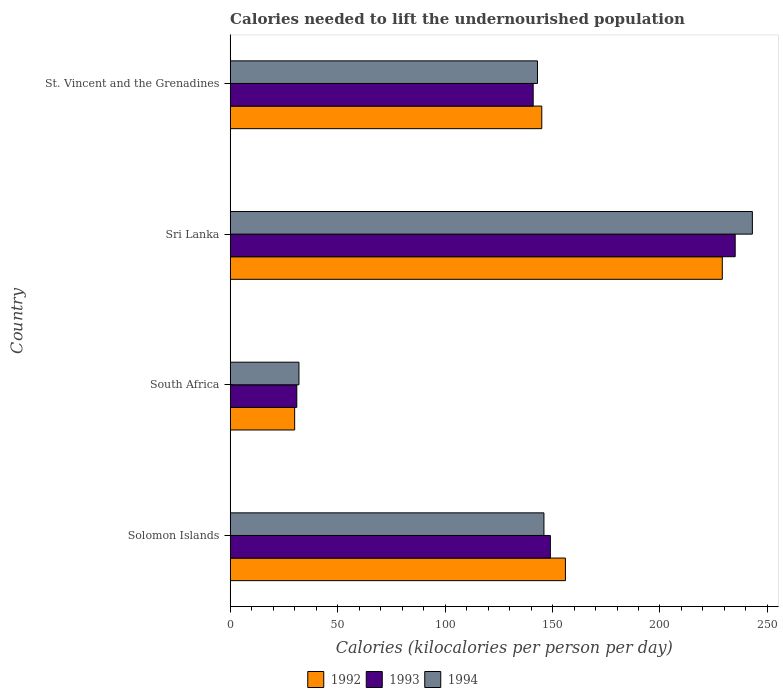How many groups of bars are there?
Offer a very short reply. 4. Are the number of bars per tick equal to the number of legend labels?
Provide a short and direct response. Yes. How many bars are there on the 1st tick from the top?
Offer a very short reply. 3. What is the label of the 1st group of bars from the top?
Your answer should be very brief. St. Vincent and the Grenadines. In how many cases, is the number of bars for a given country not equal to the number of legend labels?
Give a very brief answer. 0. What is the total calories needed to lift the undernourished population in 1994 in St. Vincent and the Grenadines?
Provide a succinct answer. 143. Across all countries, what is the maximum total calories needed to lift the undernourished population in 1992?
Your response must be concise. 229. Across all countries, what is the minimum total calories needed to lift the undernourished population in 1992?
Your response must be concise. 30. In which country was the total calories needed to lift the undernourished population in 1993 maximum?
Your answer should be very brief. Sri Lanka. In which country was the total calories needed to lift the undernourished population in 1994 minimum?
Provide a succinct answer. South Africa. What is the total total calories needed to lift the undernourished population in 1992 in the graph?
Offer a very short reply. 560. What is the difference between the total calories needed to lift the undernourished population in 1992 in Solomon Islands and that in Sri Lanka?
Your answer should be compact. -73. What is the difference between the total calories needed to lift the undernourished population in 1994 in Sri Lanka and the total calories needed to lift the undernourished population in 1993 in South Africa?
Keep it short and to the point. 212. What is the average total calories needed to lift the undernourished population in 1992 per country?
Provide a succinct answer. 140. What is the ratio of the total calories needed to lift the undernourished population in 1994 in South Africa to that in Sri Lanka?
Offer a terse response. 0.13. Is the total calories needed to lift the undernourished population in 1992 in South Africa less than that in Sri Lanka?
Your answer should be very brief. Yes. Is the difference between the total calories needed to lift the undernourished population in 1994 in South Africa and St. Vincent and the Grenadines greater than the difference between the total calories needed to lift the undernourished population in 1993 in South Africa and St. Vincent and the Grenadines?
Offer a terse response. No. What is the difference between the highest and the second highest total calories needed to lift the undernourished population in 1992?
Your answer should be compact. 73. What is the difference between the highest and the lowest total calories needed to lift the undernourished population in 1992?
Your answer should be compact. 199. What does the 2nd bar from the top in St. Vincent and the Grenadines represents?
Offer a terse response. 1993. What does the 3rd bar from the bottom in South Africa represents?
Make the answer very short. 1994. How many bars are there?
Provide a succinct answer. 12. Are all the bars in the graph horizontal?
Offer a terse response. Yes. Are the values on the major ticks of X-axis written in scientific E-notation?
Ensure brevity in your answer.  No. Does the graph contain any zero values?
Your answer should be very brief. No. How many legend labels are there?
Give a very brief answer. 3. How are the legend labels stacked?
Offer a terse response. Horizontal. What is the title of the graph?
Ensure brevity in your answer.  Calories needed to lift the undernourished population. Does "1985" appear as one of the legend labels in the graph?
Provide a short and direct response. No. What is the label or title of the X-axis?
Give a very brief answer. Calories (kilocalories per person per day). What is the label or title of the Y-axis?
Your answer should be compact. Country. What is the Calories (kilocalories per person per day) of 1992 in Solomon Islands?
Make the answer very short. 156. What is the Calories (kilocalories per person per day) of 1993 in Solomon Islands?
Provide a succinct answer. 149. What is the Calories (kilocalories per person per day) of 1994 in Solomon Islands?
Provide a succinct answer. 146. What is the Calories (kilocalories per person per day) of 1992 in South Africa?
Keep it short and to the point. 30. What is the Calories (kilocalories per person per day) in 1992 in Sri Lanka?
Your answer should be compact. 229. What is the Calories (kilocalories per person per day) of 1993 in Sri Lanka?
Provide a short and direct response. 235. What is the Calories (kilocalories per person per day) in 1994 in Sri Lanka?
Offer a terse response. 243. What is the Calories (kilocalories per person per day) in 1992 in St. Vincent and the Grenadines?
Give a very brief answer. 145. What is the Calories (kilocalories per person per day) in 1993 in St. Vincent and the Grenadines?
Provide a short and direct response. 141. What is the Calories (kilocalories per person per day) in 1994 in St. Vincent and the Grenadines?
Your response must be concise. 143. Across all countries, what is the maximum Calories (kilocalories per person per day) in 1992?
Your answer should be very brief. 229. Across all countries, what is the maximum Calories (kilocalories per person per day) of 1993?
Provide a succinct answer. 235. Across all countries, what is the maximum Calories (kilocalories per person per day) in 1994?
Your response must be concise. 243. Across all countries, what is the minimum Calories (kilocalories per person per day) of 1994?
Give a very brief answer. 32. What is the total Calories (kilocalories per person per day) in 1992 in the graph?
Give a very brief answer. 560. What is the total Calories (kilocalories per person per day) in 1993 in the graph?
Offer a terse response. 556. What is the total Calories (kilocalories per person per day) of 1994 in the graph?
Keep it short and to the point. 564. What is the difference between the Calories (kilocalories per person per day) of 1992 in Solomon Islands and that in South Africa?
Your answer should be very brief. 126. What is the difference between the Calories (kilocalories per person per day) in 1993 in Solomon Islands and that in South Africa?
Ensure brevity in your answer.  118. What is the difference between the Calories (kilocalories per person per day) of 1994 in Solomon Islands and that in South Africa?
Your response must be concise. 114. What is the difference between the Calories (kilocalories per person per day) in 1992 in Solomon Islands and that in Sri Lanka?
Provide a succinct answer. -73. What is the difference between the Calories (kilocalories per person per day) of 1993 in Solomon Islands and that in Sri Lanka?
Give a very brief answer. -86. What is the difference between the Calories (kilocalories per person per day) in 1994 in Solomon Islands and that in Sri Lanka?
Your response must be concise. -97. What is the difference between the Calories (kilocalories per person per day) in 1992 in Solomon Islands and that in St. Vincent and the Grenadines?
Make the answer very short. 11. What is the difference between the Calories (kilocalories per person per day) in 1993 in Solomon Islands and that in St. Vincent and the Grenadines?
Make the answer very short. 8. What is the difference between the Calories (kilocalories per person per day) in 1994 in Solomon Islands and that in St. Vincent and the Grenadines?
Ensure brevity in your answer.  3. What is the difference between the Calories (kilocalories per person per day) of 1992 in South Africa and that in Sri Lanka?
Offer a very short reply. -199. What is the difference between the Calories (kilocalories per person per day) in 1993 in South Africa and that in Sri Lanka?
Your answer should be compact. -204. What is the difference between the Calories (kilocalories per person per day) in 1994 in South Africa and that in Sri Lanka?
Provide a short and direct response. -211. What is the difference between the Calories (kilocalories per person per day) of 1992 in South Africa and that in St. Vincent and the Grenadines?
Your response must be concise. -115. What is the difference between the Calories (kilocalories per person per day) of 1993 in South Africa and that in St. Vincent and the Grenadines?
Give a very brief answer. -110. What is the difference between the Calories (kilocalories per person per day) in 1994 in South Africa and that in St. Vincent and the Grenadines?
Provide a short and direct response. -111. What is the difference between the Calories (kilocalories per person per day) of 1992 in Sri Lanka and that in St. Vincent and the Grenadines?
Your answer should be very brief. 84. What is the difference between the Calories (kilocalories per person per day) in 1993 in Sri Lanka and that in St. Vincent and the Grenadines?
Provide a succinct answer. 94. What is the difference between the Calories (kilocalories per person per day) in 1994 in Sri Lanka and that in St. Vincent and the Grenadines?
Your response must be concise. 100. What is the difference between the Calories (kilocalories per person per day) of 1992 in Solomon Islands and the Calories (kilocalories per person per day) of 1993 in South Africa?
Make the answer very short. 125. What is the difference between the Calories (kilocalories per person per day) of 1992 in Solomon Islands and the Calories (kilocalories per person per day) of 1994 in South Africa?
Make the answer very short. 124. What is the difference between the Calories (kilocalories per person per day) of 1993 in Solomon Islands and the Calories (kilocalories per person per day) of 1994 in South Africa?
Make the answer very short. 117. What is the difference between the Calories (kilocalories per person per day) of 1992 in Solomon Islands and the Calories (kilocalories per person per day) of 1993 in Sri Lanka?
Keep it short and to the point. -79. What is the difference between the Calories (kilocalories per person per day) of 1992 in Solomon Islands and the Calories (kilocalories per person per day) of 1994 in Sri Lanka?
Offer a very short reply. -87. What is the difference between the Calories (kilocalories per person per day) of 1993 in Solomon Islands and the Calories (kilocalories per person per day) of 1994 in Sri Lanka?
Give a very brief answer. -94. What is the difference between the Calories (kilocalories per person per day) in 1992 in Solomon Islands and the Calories (kilocalories per person per day) in 1993 in St. Vincent and the Grenadines?
Your answer should be very brief. 15. What is the difference between the Calories (kilocalories per person per day) in 1992 in South Africa and the Calories (kilocalories per person per day) in 1993 in Sri Lanka?
Ensure brevity in your answer.  -205. What is the difference between the Calories (kilocalories per person per day) in 1992 in South Africa and the Calories (kilocalories per person per day) in 1994 in Sri Lanka?
Ensure brevity in your answer.  -213. What is the difference between the Calories (kilocalories per person per day) in 1993 in South Africa and the Calories (kilocalories per person per day) in 1994 in Sri Lanka?
Keep it short and to the point. -212. What is the difference between the Calories (kilocalories per person per day) in 1992 in South Africa and the Calories (kilocalories per person per day) in 1993 in St. Vincent and the Grenadines?
Give a very brief answer. -111. What is the difference between the Calories (kilocalories per person per day) of 1992 in South Africa and the Calories (kilocalories per person per day) of 1994 in St. Vincent and the Grenadines?
Make the answer very short. -113. What is the difference between the Calories (kilocalories per person per day) in 1993 in South Africa and the Calories (kilocalories per person per day) in 1994 in St. Vincent and the Grenadines?
Ensure brevity in your answer.  -112. What is the difference between the Calories (kilocalories per person per day) of 1992 in Sri Lanka and the Calories (kilocalories per person per day) of 1993 in St. Vincent and the Grenadines?
Keep it short and to the point. 88. What is the difference between the Calories (kilocalories per person per day) of 1993 in Sri Lanka and the Calories (kilocalories per person per day) of 1994 in St. Vincent and the Grenadines?
Your response must be concise. 92. What is the average Calories (kilocalories per person per day) in 1992 per country?
Provide a succinct answer. 140. What is the average Calories (kilocalories per person per day) in 1993 per country?
Your response must be concise. 139. What is the average Calories (kilocalories per person per day) in 1994 per country?
Give a very brief answer. 141. What is the difference between the Calories (kilocalories per person per day) in 1992 and Calories (kilocalories per person per day) in 1994 in Sri Lanka?
Offer a terse response. -14. What is the difference between the Calories (kilocalories per person per day) of 1993 and Calories (kilocalories per person per day) of 1994 in Sri Lanka?
Offer a very short reply. -8. What is the ratio of the Calories (kilocalories per person per day) of 1993 in Solomon Islands to that in South Africa?
Give a very brief answer. 4.81. What is the ratio of the Calories (kilocalories per person per day) of 1994 in Solomon Islands to that in South Africa?
Offer a terse response. 4.56. What is the ratio of the Calories (kilocalories per person per day) of 1992 in Solomon Islands to that in Sri Lanka?
Provide a short and direct response. 0.68. What is the ratio of the Calories (kilocalories per person per day) in 1993 in Solomon Islands to that in Sri Lanka?
Your answer should be compact. 0.63. What is the ratio of the Calories (kilocalories per person per day) of 1994 in Solomon Islands to that in Sri Lanka?
Offer a terse response. 0.6. What is the ratio of the Calories (kilocalories per person per day) in 1992 in Solomon Islands to that in St. Vincent and the Grenadines?
Provide a succinct answer. 1.08. What is the ratio of the Calories (kilocalories per person per day) of 1993 in Solomon Islands to that in St. Vincent and the Grenadines?
Keep it short and to the point. 1.06. What is the ratio of the Calories (kilocalories per person per day) of 1994 in Solomon Islands to that in St. Vincent and the Grenadines?
Your answer should be very brief. 1.02. What is the ratio of the Calories (kilocalories per person per day) in 1992 in South Africa to that in Sri Lanka?
Give a very brief answer. 0.13. What is the ratio of the Calories (kilocalories per person per day) in 1993 in South Africa to that in Sri Lanka?
Keep it short and to the point. 0.13. What is the ratio of the Calories (kilocalories per person per day) in 1994 in South Africa to that in Sri Lanka?
Your answer should be very brief. 0.13. What is the ratio of the Calories (kilocalories per person per day) of 1992 in South Africa to that in St. Vincent and the Grenadines?
Provide a short and direct response. 0.21. What is the ratio of the Calories (kilocalories per person per day) of 1993 in South Africa to that in St. Vincent and the Grenadines?
Your answer should be very brief. 0.22. What is the ratio of the Calories (kilocalories per person per day) in 1994 in South Africa to that in St. Vincent and the Grenadines?
Your answer should be compact. 0.22. What is the ratio of the Calories (kilocalories per person per day) in 1992 in Sri Lanka to that in St. Vincent and the Grenadines?
Your answer should be very brief. 1.58. What is the ratio of the Calories (kilocalories per person per day) in 1993 in Sri Lanka to that in St. Vincent and the Grenadines?
Give a very brief answer. 1.67. What is the ratio of the Calories (kilocalories per person per day) in 1994 in Sri Lanka to that in St. Vincent and the Grenadines?
Make the answer very short. 1.7. What is the difference between the highest and the second highest Calories (kilocalories per person per day) in 1992?
Offer a very short reply. 73. What is the difference between the highest and the second highest Calories (kilocalories per person per day) of 1994?
Ensure brevity in your answer.  97. What is the difference between the highest and the lowest Calories (kilocalories per person per day) of 1992?
Provide a succinct answer. 199. What is the difference between the highest and the lowest Calories (kilocalories per person per day) of 1993?
Keep it short and to the point. 204. What is the difference between the highest and the lowest Calories (kilocalories per person per day) in 1994?
Offer a very short reply. 211. 